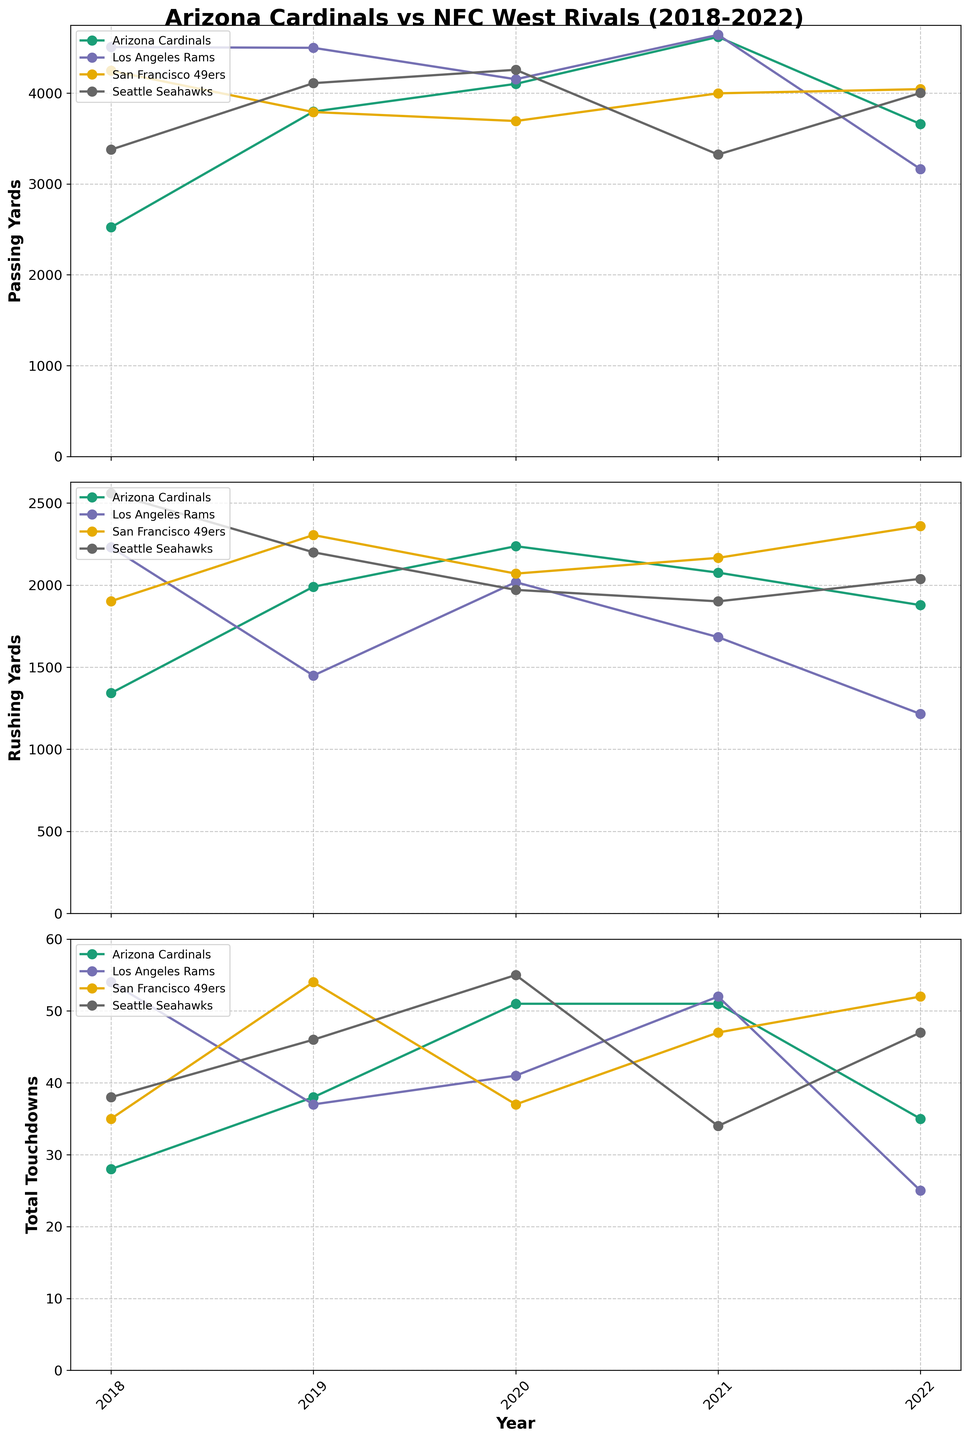Which team had the most passing yards in 2020? Look at the 'Passing Yards' subplot and find the data points for 2020. Identify the highest value and the corresponding team.
Answer: Seattle Seahawks How did the Arizona Cardinals' rushing yards trend from 2018 to 2022? Track the line representing Arizona Cardinals in the 'Rushing Yards' subplot from 2018 to 2022. Observe if it generally increases, decreases, or fluctuates.
Answer: Increased Which team scored the most total touchdowns in 2021, and how many did they score? Refer to the 'Total Touchdowns' subplot. Find the highest value for 2021 and the team associated with it.
Answer: Los Angeles Rams, 52 Compare the total touchdowns of the Arizona Cardinals and Seattle Seahawks in 2019. Which team had more, and by how much? Look at the 'Total Touchdowns' subplot for 2019 data points. Subtract the Arizona Cardinals' value from the Seattle Seahawks' value.
Answer: Seattle Seahawks, 8 more Which team had the lowest passing yards in 2018? Check the 'Passing Yards' subplot and identify the lowest data point for 2018, then find the corresponding team.
Answer: Arizona Cardinals What is the average rushing yards of the San Francisco 49ers from 2018 to 2022? Find the San Francisco 49ers' data points in the 'Rushing Yards' subplot. Add these values and divide by the number of years (5).
Answer: 2159.6 Which team had the most consistent total touchdowns (least variance) over the years? Examine the 'Total Touchdowns' subplot for each team. The team with values closest to each other (least spread out) will have the least variance.
Answer: Arizona Cardinals Did the Los Angeles Rams’ passing yards increase or decrease from 2018 to 2022? Track the line representing Los Angeles Rams in the 'Passing Yards' subplot from 2018 to 2022. Determine if it generally goes up or down.
Answer: Decrease In which year did the Seattle Seahawks have their highest rushing yards, and how much was it? Find the highest data point for Seattle Seahawks in the 'Rushing Yards' subplot and check the corresponding year and value.
Answer: 2018, 2560 Which team showed the greatest improvement in total touchdowns from 2018 to 2020? Compare each team's total touchdowns from 2018 to 2020 in the 'Total Touchdowns' subplot. Calculate the difference for each team and identify the greatest increase.
Answer: Arizona Cardinals 